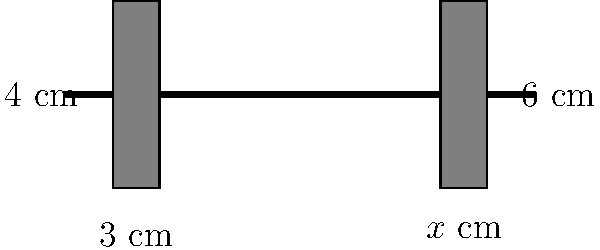In a weightlifting competition, two rectangular weight plates are placed on a barbell. The plate on the left has dimensions of 3 cm by 4 cm. The plate on the right has a height of 6 cm and the same area as the left plate. If the two plates are congruent, what is the width ($x$) of the right plate in centimeters? Let's solve this step-by-step:

1) First, we know that congruent shapes have the same area and the same dimensions.

2) The area of the left plate is:
   $A_{\text{left}} = 3 \text{ cm} \times 4 \text{ cm} = 12 \text{ cm}^2$

3) Since the plates are congruent, the area of the right plate must also be 12 cm².

4) We're told that the height of the right plate is 6 cm. Let's call the width $x$ cm.

5) The area of the right plate can be expressed as:
   $A_{\text{right}} = 6x \text{ cm}^2$

6) Since the areas are equal:
   $12 \text{ cm}^2 = 6x \text{ cm}^2$

7) Solving for $x$:
   $x = 12 \div 6 = 2$

8) Therefore, the width of the right plate is 2 cm.

9) We can verify: $2 \text{ cm} \times 6 \text{ cm} = 12 \text{ cm}^2$, which matches the area of the left plate.

10) The plates are indeed congruent, as they both have dimensions of 3 cm by 4 cm (rotated 90° for the right plate).
Answer: 2 cm 